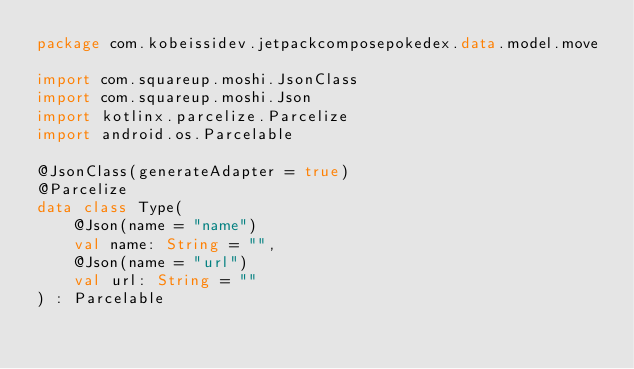Convert code to text. <code><loc_0><loc_0><loc_500><loc_500><_Kotlin_>package com.kobeissidev.jetpackcomposepokedex.data.model.move

import com.squareup.moshi.JsonClass
import com.squareup.moshi.Json
import kotlinx.parcelize.Parcelize
import android.os.Parcelable

@JsonClass(generateAdapter = true)
@Parcelize
data class Type(
    @Json(name = "name")
    val name: String = "",
    @Json(name = "url")
    val url: String = ""
) : Parcelable</code> 